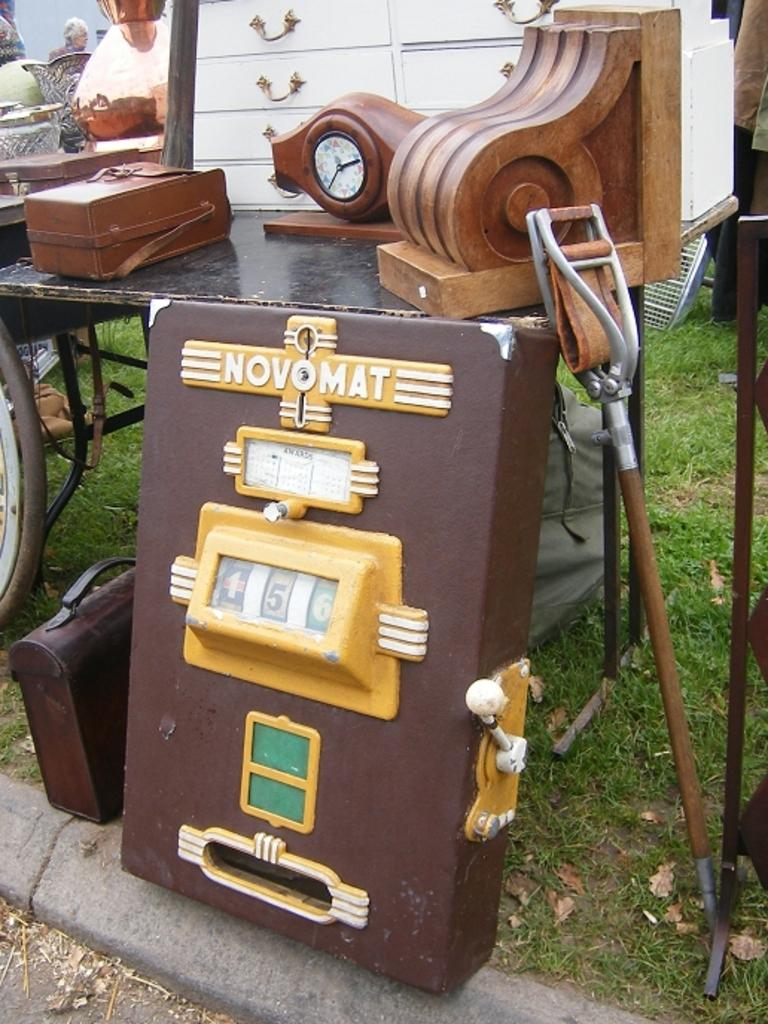What type of furniture is present in the image? There are tables in the image. What tool is visible in the image? A shovel is visible in the image. What type of ground surface is at the bottom of the image? There is grass at the bottom of the image. What object might be used for carrying documents or personal items? A briefcase is present in the image. What is the flat, rectangular object visible in the image? A board is visible in the image. Where is the person located in the image? There is a person on the left side of the image. What type of coal is being used to heat the stove in the image? There is no stove or coal present in the image. How does the person change the temperature of the room using the stove in the image? There is no stove or temperature control in the image. 